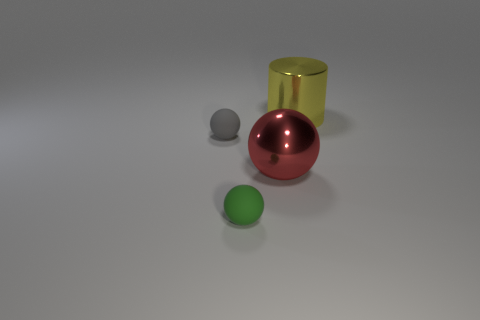Add 2 blue rubber cubes. How many objects exist? 6 Subtract all cylinders. How many objects are left? 3 Add 1 tiny gray metallic spheres. How many tiny gray metallic spheres exist? 1 Subtract 0 cyan cubes. How many objects are left? 4 Subtract all tiny purple metal cylinders. Subtract all big spheres. How many objects are left? 3 Add 1 tiny green spheres. How many tiny green spheres are left? 2 